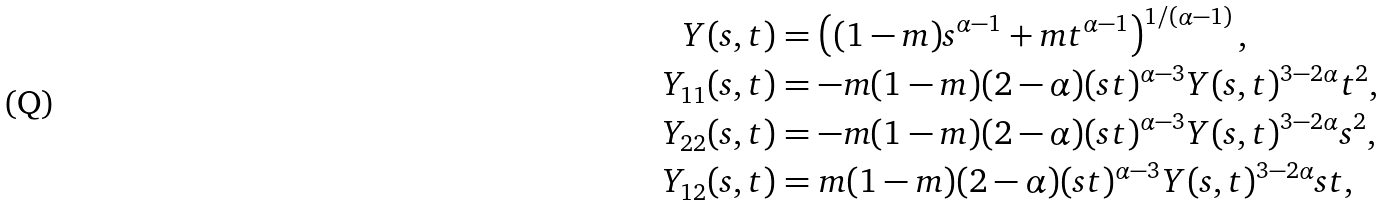Convert formula to latex. <formula><loc_0><loc_0><loc_500><loc_500>Y ( s , t ) & = \left ( ( 1 - m ) s ^ { \alpha - 1 } + m t ^ { \alpha - 1 } \right ) ^ { 1 / ( \alpha - 1 ) } , \\ Y _ { 1 1 } ( s , t ) & = - m ( 1 - m ) ( 2 - \alpha ) ( s t ) ^ { \alpha - 3 } Y ( s , t ) ^ { 3 - 2 \alpha } t ^ { 2 } , \\ Y _ { 2 2 } ( s , t ) & = - m ( 1 - m ) ( 2 - \alpha ) ( s t ) ^ { \alpha - 3 } Y ( s , t ) ^ { 3 - 2 \alpha } s ^ { 2 } , \\ Y _ { 1 2 } ( s , t ) & = m ( 1 - m ) ( 2 - \alpha ) ( s t ) ^ { \alpha - 3 } Y ( s , t ) ^ { 3 - 2 \alpha } s t ,</formula> 